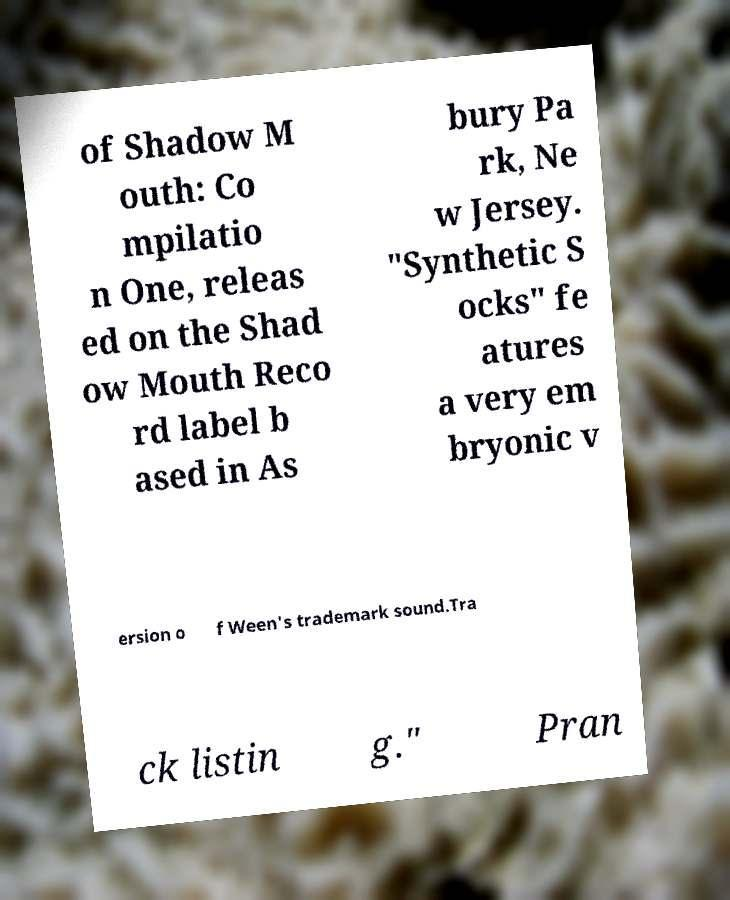Please read and relay the text visible in this image. What does it say? of Shadow M outh: Co mpilatio n One, releas ed on the Shad ow Mouth Reco rd label b ased in As bury Pa rk, Ne w Jersey. "Synthetic S ocks" fe atures a very em bryonic v ersion o f Ween's trademark sound.Tra ck listin g." Pran 